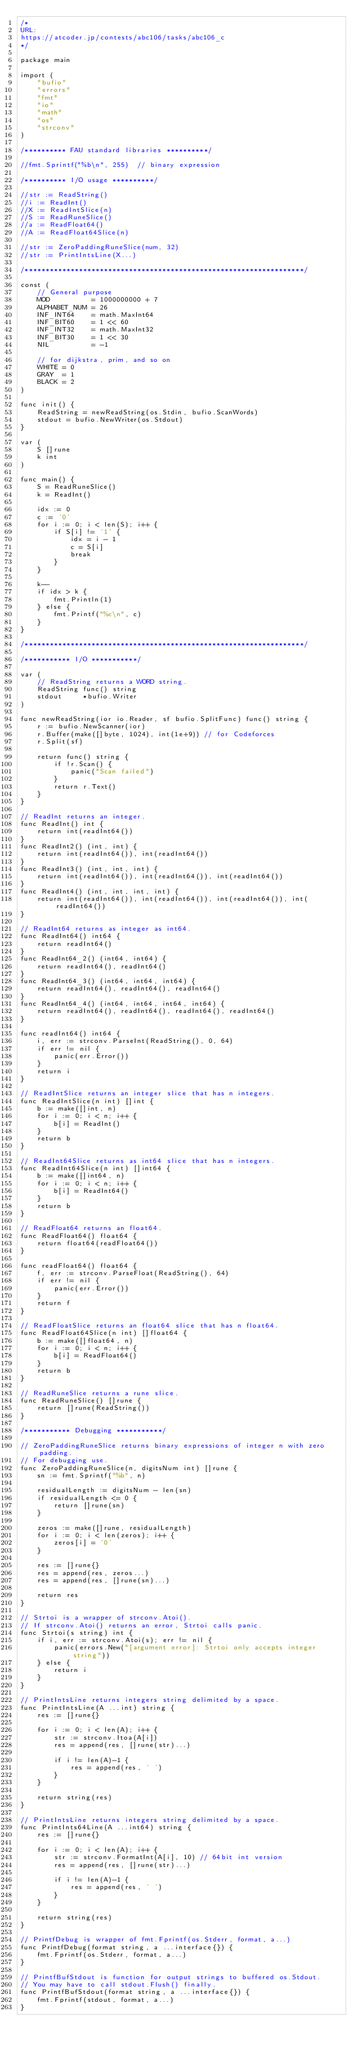<code> <loc_0><loc_0><loc_500><loc_500><_Go_>/*
URL:
https://atcoder.jp/contests/abc106/tasks/abc106_c
*/

package main

import (
	"bufio"
	"errors"
	"fmt"
	"io"
	"math"
	"os"
	"strconv"
)

/********** FAU standard libraries **********/

//fmt.Sprintf("%b\n", 255) 	// binary expression

/********** I/O usage **********/

//str := ReadString()
//i := ReadInt()
//X := ReadIntSlice(n)
//S := ReadRuneSlice()
//a := ReadFloat64()
//A := ReadFloat64Slice(n)

//str := ZeroPaddingRuneSlice(num, 32)
//str := PrintIntsLine(X...)

/*******************************************************************/

const (
	// General purpose
	MOD          = 1000000000 + 7
	ALPHABET_NUM = 26
	INF_INT64    = math.MaxInt64
	INF_BIT60    = 1 << 60
	INF_INT32    = math.MaxInt32
	INF_BIT30    = 1 << 30
	NIL          = -1

	// for dijkstra, prim, and so on
	WHITE = 0
	GRAY  = 1
	BLACK = 2
)

func init() {
	ReadString = newReadString(os.Stdin, bufio.ScanWords)
	stdout = bufio.NewWriter(os.Stdout)
}

var (
	S []rune
	k int
)

func main() {
	S = ReadRuneSlice()
	k = ReadInt()

	idx := 0
	c := '0'
	for i := 0; i < len(S); i++ {
		if S[i] != '1' {
			idx = i - 1
			c = S[i]
			break
		}
	}

	k--
	if idx > k {
		fmt.Println(1)
	} else {
		fmt.Printf("%c\n", c)
	}
}

/*******************************************************************/

/*********** I/O ***********/

var (
	// ReadString returns a WORD string.
	ReadString func() string
	stdout     *bufio.Writer
)

func newReadString(ior io.Reader, sf bufio.SplitFunc) func() string {
	r := bufio.NewScanner(ior)
	r.Buffer(make([]byte, 1024), int(1e+9)) // for Codeforces
	r.Split(sf)

	return func() string {
		if !r.Scan() {
			panic("Scan failed")
		}
		return r.Text()
	}
}

// ReadInt returns an integer.
func ReadInt() int {
	return int(readInt64())
}
func ReadInt2() (int, int) {
	return int(readInt64()), int(readInt64())
}
func ReadInt3() (int, int, int) {
	return int(readInt64()), int(readInt64()), int(readInt64())
}
func ReadInt4() (int, int, int, int) {
	return int(readInt64()), int(readInt64()), int(readInt64()), int(readInt64())
}

// ReadInt64 returns as integer as int64.
func ReadInt64() int64 {
	return readInt64()
}
func ReadInt64_2() (int64, int64) {
	return readInt64(), readInt64()
}
func ReadInt64_3() (int64, int64, int64) {
	return readInt64(), readInt64(), readInt64()
}
func ReadInt64_4() (int64, int64, int64, int64) {
	return readInt64(), readInt64(), readInt64(), readInt64()
}

func readInt64() int64 {
	i, err := strconv.ParseInt(ReadString(), 0, 64)
	if err != nil {
		panic(err.Error())
	}
	return i
}

// ReadIntSlice returns an integer slice that has n integers.
func ReadIntSlice(n int) []int {
	b := make([]int, n)
	for i := 0; i < n; i++ {
		b[i] = ReadInt()
	}
	return b
}

// ReadInt64Slice returns as int64 slice that has n integers.
func ReadInt64Slice(n int) []int64 {
	b := make([]int64, n)
	for i := 0; i < n; i++ {
		b[i] = ReadInt64()
	}
	return b
}

// ReadFloat64 returns an float64.
func ReadFloat64() float64 {
	return float64(readFloat64())
}

func readFloat64() float64 {
	f, err := strconv.ParseFloat(ReadString(), 64)
	if err != nil {
		panic(err.Error())
	}
	return f
}

// ReadFloatSlice returns an float64 slice that has n float64.
func ReadFloat64Slice(n int) []float64 {
	b := make([]float64, n)
	for i := 0; i < n; i++ {
		b[i] = ReadFloat64()
	}
	return b
}

// ReadRuneSlice returns a rune slice.
func ReadRuneSlice() []rune {
	return []rune(ReadString())
}

/*********** Debugging ***********/

// ZeroPaddingRuneSlice returns binary expressions of integer n with zero padding.
// For debugging use.
func ZeroPaddingRuneSlice(n, digitsNum int) []rune {
	sn := fmt.Sprintf("%b", n)

	residualLength := digitsNum - len(sn)
	if residualLength <= 0 {
		return []rune(sn)
	}

	zeros := make([]rune, residualLength)
	for i := 0; i < len(zeros); i++ {
		zeros[i] = '0'
	}

	res := []rune{}
	res = append(res, zeros...)
	res = append(res, []rune(sn)...)

	return res
}

// Strtoi is a wrapper of strconv.Atoi().
// If strconv.Atoi() returns an error, Strtoi calls panic.
func Strtoi(s string) int {
	if i, err := strconv.Atoi(s); err != nil {
		panic(errors.New("[argument error]: Strtoi only accepts integer string"))
	} else {
		return i
	}
}

// PrintIntsLine returns integers string delimited by a space.
func PrintIntsLine(A ...int) string {
	res := []rune{}

	for i := 0; i < len(A); i++ {
		str := strconv.Itoa(A[i])
		res = append(res, []rune(str)...)

		if i != len(A)-1 {
			res = append(res, ' ')
		}
	}

	return string(res)
}

// PrintIntsLine returns integers string delimited by a space.
func PrintInts64Line(A ...int64) string {
	res := []rune{}

	for i := 0; i < len(A); i++ {
		str := strconv.FormatInt(A[i], 10) // 64bit int version
		res = append(res, []rune(str)...)

		if i != len(A)-1 {
			res = append(res, ' ')
		}
	}

	return string(res)
}

// PrintfDebug is wrapper of fmt.Fprintf(os.Stderr, format, a...)
func PrintfDebug(format string, a ...interface{}) {
	fmt.Fprintf(os.Stderr, format, a...)
}

// PrintfBufStdout is function for output strings to buffered os.Stdout.
// You may have to call stdout.Flush() finally.
func PrintfBufStdout(format string, a ...interface{}) {
	fmt.Fprintf(stdout, format, a...)
}
</code> 